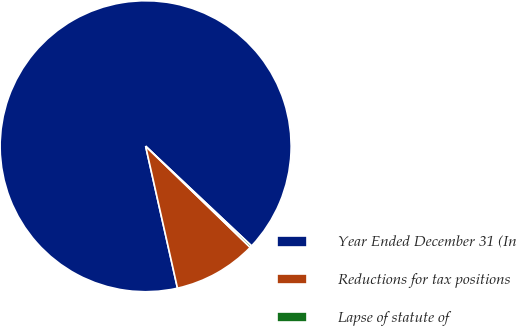Convert chart. <chart><loc_0><loc_0><loc_500><loc_500><pie_chart><fcel>Year Ended December 31 (In<fcel>Reductions for tax positions<fcel>Lapse of statute of<nl><fcel>90.52%<fcel>9.25%<fcel>0.22%<nl></chart> 